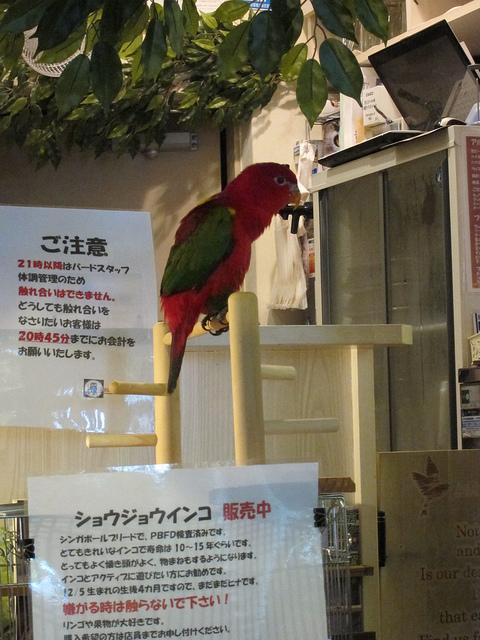Is the bird pictured native to Iceland?
Concise answer only. No. What language is written on the sign?
Be succinct. Chinese. Is this in an Asian country?
Short answer required. Yes. 